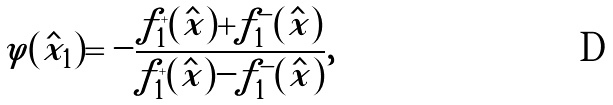Convert formula to latex. <formula><loc_0><loc_0><loc_500><loc_500>\varphi ( \hat { x } _ { 1 } ) = - \frac { f _ { 1 } ^ { + } ( \hat { x } ) + f _ { 1 } ^ { - } ( \hat { x } ) } { f _ { 1 } ^ { + } ( \hat { x } ) - f _ { 1 } ^ { - } ( \hat { x } ) } ,</formula> 